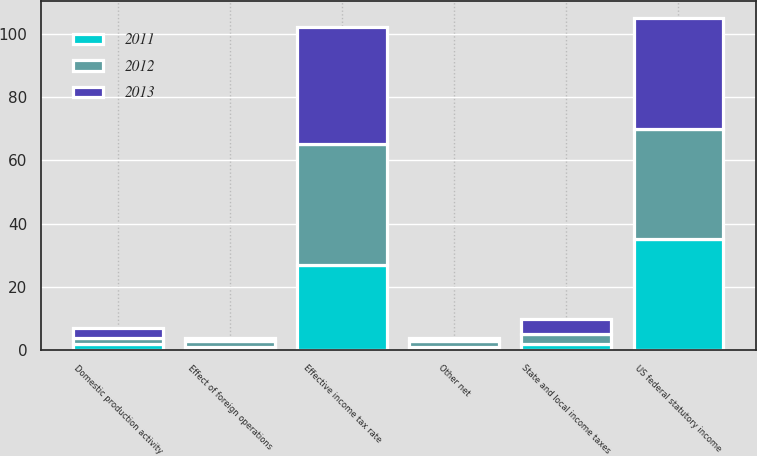<chart> <loc_0><loc_0><loc_500><loc_500><stacked_bar_chart><ecel><fcel>US federal statutory income<fcel>State and local income taxes<fcel>Effect of foreign operations<fcel>Domestic production activity<fcel>Other net<fcel>Effective income tax rate<nl><fcel>2012<fcel>35<fcel>3<fcel>2<fcel>2<fcel>2<fcel>38<nl><fcel>2013<fcel>35<fcel>5<fcel>1<fcel>3<fcel>1<fcel>37<nl><fcel>2011<fcel>35<fcel>2<fcel>1<fcel>2<fcel>1<fcel>27<nl></chart> 